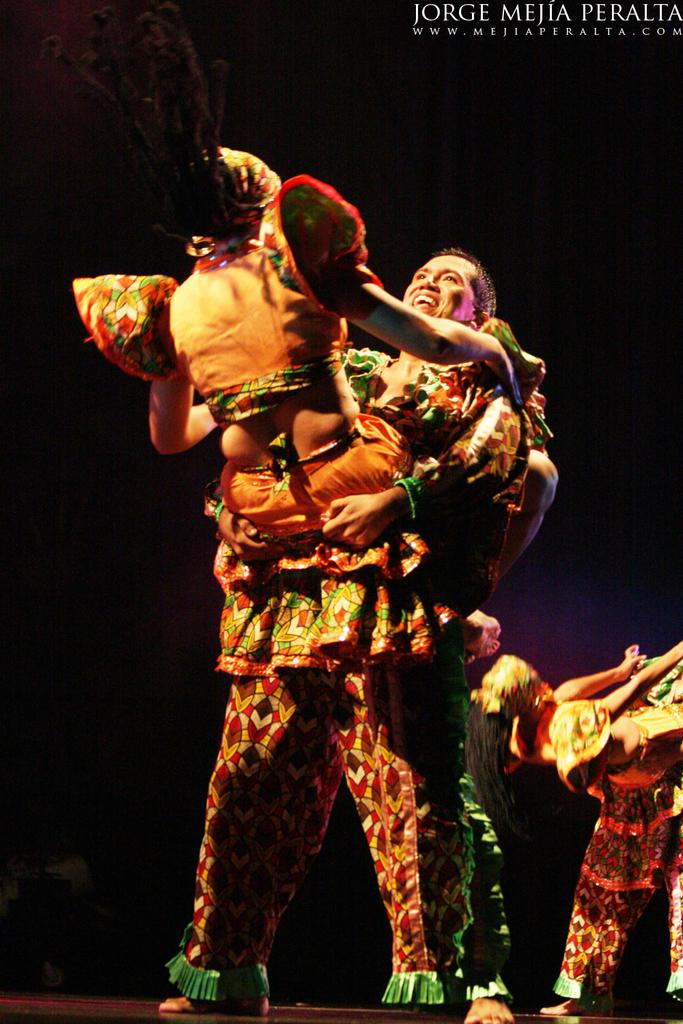What are the people in the image doing? The people in the image are dancing. Can you describe the background of the image? The background of the image is dark. Is there any text visible in the image? Yes, there is some text in the top right of the image. What is the value of the brother's advertisement in the image? There is no brother or advertisement present in the image, so it's not possible to determine a value. 